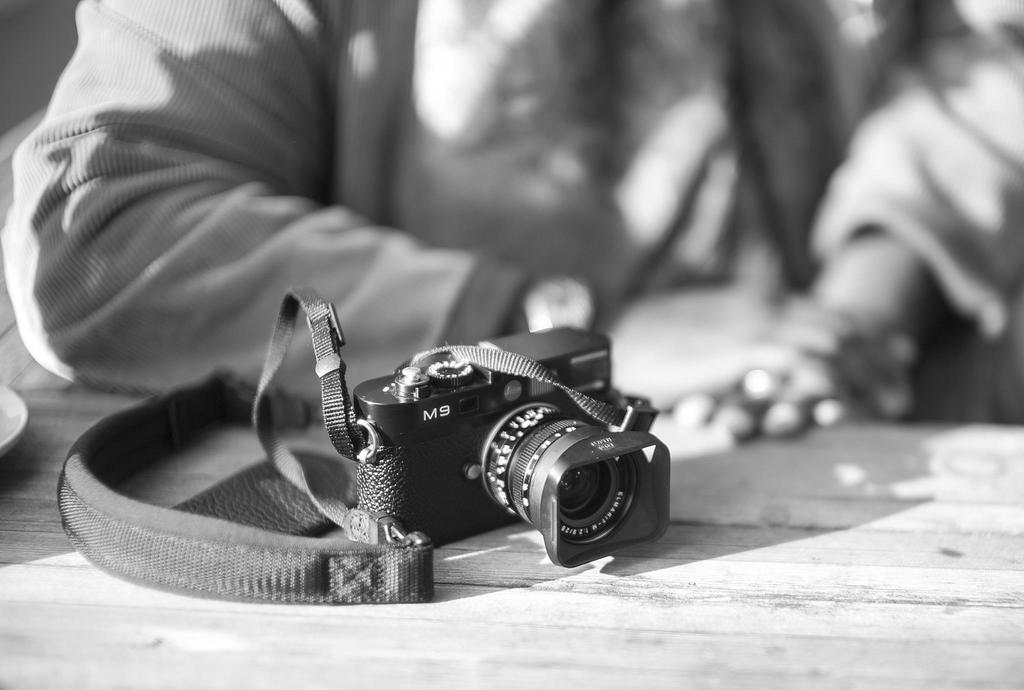What 2 letters are on the camera?
Give a very brief answer. M9. What number is in the name of the item?
Your answer should be very brief. 9. 